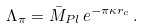Convert formula to latex. <formula><loc_0><loc_0><loc_500><loc_500>\Lambda _ { \pi } = \bar { M } _ { P l } \, e ^ { - \pi \kappa r _ { c } } \, .</formula> 